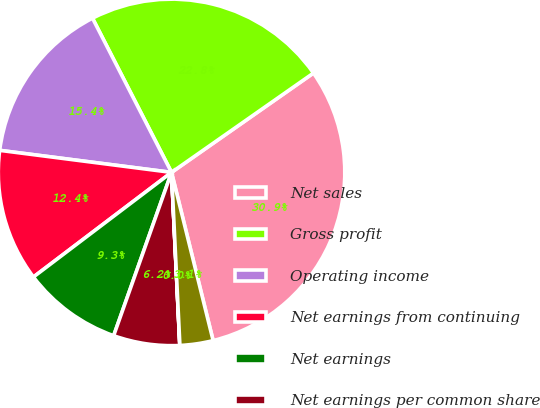Convert chart to OTSL. <chart><loc_0><loc_0><loc_500><loc_500><pie_chart><fcel>Net sales<fcel>Gross profit<fcel>Operating income<fcel>Net earnings from continuing<fcel>Net earnings<fcel>Net earnings per common share<fcel>Diluted<fcel>Basic<nl><fcel>30.86%<fcel>22.82%<fcel>15.43%<fcel>12.35%<fcel>9.26%<fcel>6.18%<fcel>0.01%<fcel>3.09%<nl></chart> 